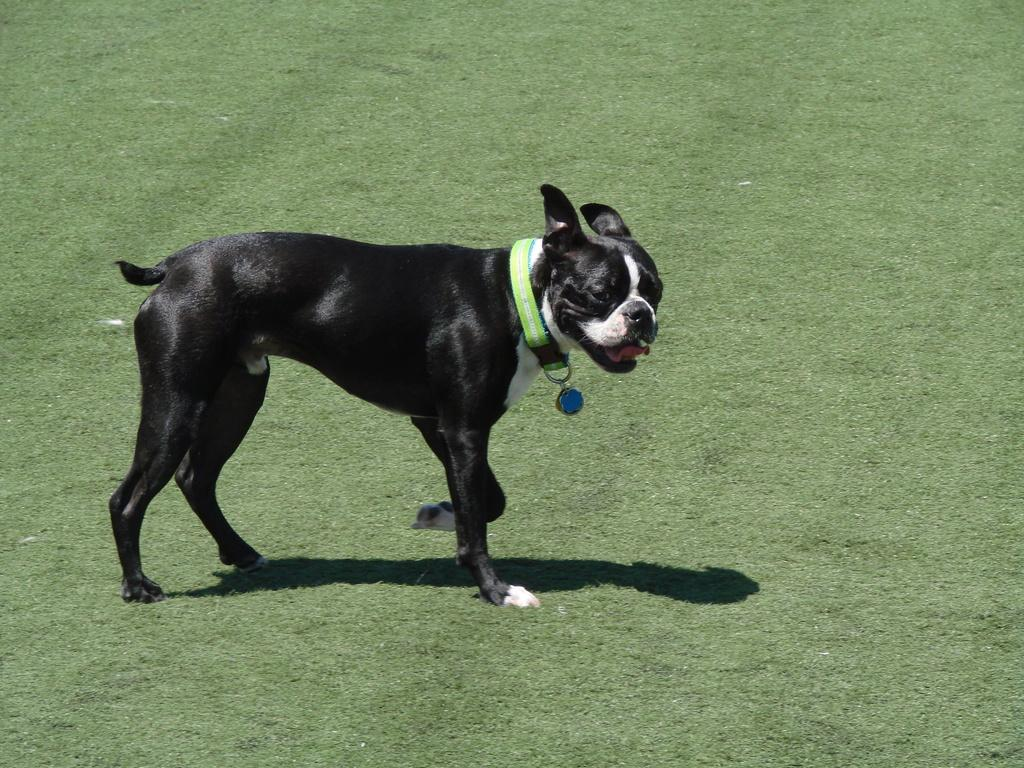Where was the picture taken? The picture was taken outside. What type of animal is in the image? There is a black color dog in the image. What is the dog doing in the image? The dog appears to be walking. What can be seen on the ground in the image? The ground is visible in the image, and it is covered with green grass. What type of desk is visible in the image? There is no desk present in the image; it is taken outside with a dog walking on green grass. Is there a woman wearing a suit in the image? There is no woman or suit present in the image; it features a black color dog walking on green grass. 